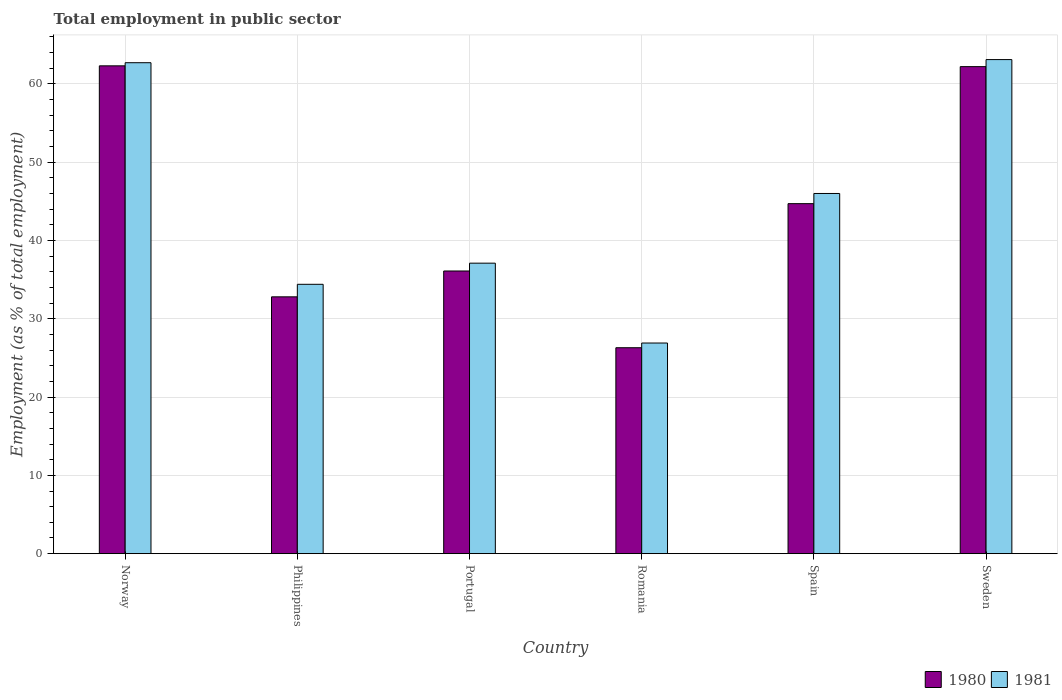How many different coloured bars are there?
Provide a short and direct response. 2. Are the number of bars per tick equal to the number of legend labels?
Keep it short and to the point. Yes. Are the number of bars on each tick of the X-axis equal?
Provide a short and direct response. Yes. In how many cases, is the number of bars for a given country not equal to the number of legend labels?
Give a very brief answer. 0. What is the employment in public sector in 1981 in Sweden?
Offer a terse response. 63.1. Across all countries, what is the maximum employment in public sector in 1980?
Provide a succinct answer. 62.3. Across all countries, what is the minimum employment in public sector in 1981?
Make the answer very short. 26.9. In which country was the employment in public sector in 1980 minimum?
Provide a short and direct response. Romania. What is the total employment in public sector in 1980 in the graph?
Your answer should be very brief. 264.4. What is the difference between the employment in public sector in 1980 in Portugal and the employment in public sector in 1981 in Romania?
Keep it short and to the point. 9.2. What is the average employment in public sector in 1980 per country?
Make the answer very short. 44.07. What is the ratio of the employment in public sector in 1980 in Norway to that in Romania?
Give a very brief answer. 2.37. What is the difference between the highest and the second highest employment in public sector in 1980?
Make the answer very short. 17.5. What is the difference between the highest and the lowest employment in public sector in 1980?
Ensure brevity in your answer.  36. Is the sum of the employment in public sector in 1980 in Philippines and Sweden greater than the maximum employment in public sector in 1981 across all countries?
Keep it short and to the point. Yes. How many bars are there?
Provide a succinct answer. 12. Are all the bars in the graph horizontal?
Your answer should be very brief. No. How many countries are there in the graph?
Offer a very short reply. 6. Are the values on the major ticks of Y-axis written in scientific E-notation?
Your response must be concise. No. Does the graph contain any zero values?
Keep it short and to the point. No. Does the graph contain grids?
Your answer should be compact. Yes. Where does the legend appear in the graph?
Offer a very short reply. Bottom right. How many legend labels are there?
Provide a succinct answer. 2. What is the title of the graph?
Your answer should be very brief. Total employment in public sector. Does "1973" appear as one of the legend labels in the graph?
Offer a terse response. No. What is the label or title of the X-axis?
Your answer should be very brief. Country. What is the label or title of the Y-axis?
Your answer should be compact. Employment (as % of total employment). What is the Employment (as % of total employment) of 1980 in Norway?
Provide a succinct answer. 62.3. What is the Employment (as % of total employment) of 1981 in Norway?
Provide a succinct answer. 62.7. What is the Employment (as % of total employment) of 1980 in Philippines?
Offer a very short reply. 32.8. What is the Employment (as % of total employment) in 1981 in Philippines?
Give a very brief answer. 34.4. What is the Employment (as % of total employment) of 1980 in Portugal?
Offer a very short reply. 36.1. What is the Employment (as % of total employment) of 1981 in Portugal?
Provide a succinct answer. 37.1. What is the Employment (as % of total employment) of 1980 in Romania?
Offer a very short reply. 26.3. What is the Employment (as % of total employment) of 1981 in Romania?
Offer a terse response. 26.9. What is the Employment (as % of total employment) of 1980 in Spain?
Offer a terse response. 44.7. What is the Employment (as % of total employment) in 1981 in Spain?
Your answer should be very brief. 46. What is the Employment (as % of total employment) of 1980 in Sweden?
Make the answer very short. 62.2. What is the Employment (as % of total employment) of 1981 in Sweden?
Offer a terse response. 63.1. Across all countries, what is the maximum Employment (as % of total employment) of 1980?
Ensure brevity in your answer.  62.3. Across all countries, what is the maximum Employment (as % of total employment) in 1981?
Offer a terse response. 63.1. Across all countries, what is the minimum Employment (as % of total employment) of 1980?
Offer a terse response. 26.3. Across all countries, what is the minimum Employment (as % of total employment) of 1981?
Your answer should be compact. 26.9. What is the total Employment (as % of total employment) of 1980 in the graph?
Your response must be concise. 264.4. What is the total Employment (as % of total employment) in 1981 in the graph?
Offer a terse response. 270.2. What is the difference between the Employment (as % of total employment) of 1980 in Norway and that in Philippines?
Your answer should be compact. 29.5. What is the difference between the Employment (as % of total employment) of 1981 in Norway and that in Philippines?
Ensure brevity in your answer.  28.3. What is the difference between the Employment (as % of total employment) in 1980 in Norway and that in Portugal?
Offer a terse response. 26.2. What is the difference between the Employment (as % of total employment) of 1981 in Norway and that in Portugal?
Your answer should be compact. 25.6. What is the difference between the Employment (as % of total employment) of 1980 in Norway and that in Romania?
Your answer should be very brief. 36. What is the difference between the Employment (as % of total employment) in 1981 in Norway and that in Romania?
Your answer should be very brief. 35.8. What is the difference between the Employment (as % of total employment) of 1981 in Norway and that in Spain?
Offer a very short reply. 16.7. What is the difference between the Employment (as % of total employment) in 1981 in Norway and that in Sweden?
Keep it short and to the point. -0.4. What is the difference between the Employment (as % of total employment) of 1981 in Philippines and that in Portugal?
Your response must be concise. -2.7. What is the difference between the Employment (as % of total employment) of 1981 in Philippines and that in Romania?
Your answer should be very brief. 7.5. What is the difference between the Employment (as % of total employment) of 1980 in Philippines and that in Spain?
Give a very brief answer. -11.9. What is the difference between the Employment (as % of total employment) in 1981 in Philippines and that in Spain?
Provide a short and direct response. -11.6. What is the difference between the Employment (as % of total employment) of 1980 in Philippines and that in Sweden?
Your answer should be compact. -29.4. What is the difference between the Employment (as % of total employment) in 1981 in Philippines and that in Sweden?
Offer a very short reply. -28.7. What is the difference between the Employment (as % of total employment) of 1980 in Portugal and that in Sweden?
Your answer should be compact. -26.1. What is the difference between the Employment (as % of total employment) of 1981 in Portugal and that in Sweden?
Make the answer very short. -26. What is the difference between the Employment (as % of total employment) in 1980 in Romania and that in Spain?
Your answer should be compact. -18.4. What is the difference between the Employment (as % of total employment) in 1981 in Romania and that in Spain?
Provide a succinct answer. -19.1. What is the difference between the Employment (as % of total employment) of 1980 in Romania and that in Sweden?
Ensure brevity in your answer.  -35.9. What is the difference between the Employment (as % of total employment) in 1981 in Romania and that in Sweden?
Provide a short and direct response. -36.2. What is the difference between the Employment (as % of total employment) in 1980 in Spain and that in Sweden?
Your answer should be compact. -17.5. What is the difference between the Employment (as % of total employment) in 1981 in Spain and that in Sweden?
Keep it short and to the point. -17.1. What is the difference between the Employment (as % of total employment) in 1980 in Norway and the Employment (as % of total employment) in 1981 in Philippines?
Provide a succinct answer. 27.9. What is the difference between the Employment (as % of total employment) of 1980 in Norway and the Employment (as % of total employment) of 1981 in Portugal?
Provide a succinct answer. 25.2. What is the difference between the Employment (as % of total employment) of 1980 in Norway and the Employment (as % of total employment) of 1981 in Romania?
Provide a short and direct response. 35.4. What is the difference between the Employment (as % of total employment) of 1980 in Norway and the Employment (as % of total employment) of 1981 in Spain?
Provide a short and direct response. 16.3. What is the difference between the Employment (as % of total employment) in 1980 in Philippines and the Employment (as % of total employment) in 1981 in Portugal?
Make the answer very short. -4.3. What is the difference between the Employment (as % of total employment) in 1980 in Philippines and the Employment (as % of total employment) in 1981 in Sweden?
Offer a terse response. -30.3. What is the difference between the Employment (as % of total employment) in 1980 in Portugal and the Employment (as % of total employment) in 1981 in Romania?
Offer a terse response. 9.2. What is the difference between the Employment (as % of total employment) in 1980 in Portugal and the Employment (as % of total employment) in 1981 in Sweden?
Provide a short and direct response. -27. What is the difference between the Employment (as % of total employment) of 1980 in Romania and the Employment (as % of total employment) of 1981 in Spain?
Provide a short and direct response. -19.7. What is the difference between the Employment (as % of total employment) of 1980 in Romania and the Employment (as % of total employment) of 1981 in Sweden?
Give a very brief answer. -36.8. What is the difference between the Employment (as % of total employment) of 1980 in Spain and the Employment (as % of total employment) of 1981 in Sweden?
Your answer should be very brief. -18.4. What is the average Employment (as % of total employment) of 1980 per country?
Provide a short and direct response. 44.07. What is the average Employment (as % of total employment) of 1981 per country?
Give a very brief answer. 45.03. What is the difference between the Employment (as % of total employment) in 1980 and Employment (as % of total employment) in 1981 in Norway?
Keep it short and to the point. -0.4. What is the difference between the Employment (as % of total employment) of 1980 and Employment (as % of total employment) of 1981 in Philippines?
Provide a short and direct response. -1.6. What is the difference between the Employment (as % of total employment) of 1980 and Employment (as % of total employment) of 1981 in Spain?
Give a very brief answer. -1.3. What is the difference between the Employment (as % of total employment) of 1980 and Employment (as % of total employment) of 1981 in Sweden?
Provide a short and direct response. -0.9. What is the ratio of the Employment (as % of total employment) of 1980 in Norway to that in Philippines?
Make the answer very short. 1.9. What is the ratio of the Employment (as % of total employment) of 1981 in Norway to that in Philippines?
Keep it short and to the point. 1.82. What is the ratio of the Employment (as % of total employment) of 1980 in Norway to that in Portugal?
Offer a terse response. 1.73. What is the ratio of the Employment (as % of total employment) of 1981 in Norway to that in Portugal?
Provide a succinct answer. 1.69. What is the ratio of the Employment (as % of total employment) in 1980 in Norway to that in Romania?
Keep it short and to the point. 2.37. What is the ratio of the Employment (as % of total employment) of 1981 in Norway to that in Romania?
Your response must be concise. 2.33. What is the ratio of the Employment (as % of total employment) of 1980 in Norway to that in Spain?
Your response must be concise. 1.39. What is the ratio of the Employment (as % of total employment) of 1981 in Norway to that in Spain?
Give a very brief answer. 1.36. What is the ratio of the Employment (as % of total employment) of 1980 in Norway to that in Sweden?
Offer a terse response. 1. What is the ratio of the Employment (as % of total employment) of 1980 in Philippines to that in Portugal?
Your answer should be very brief. 0.91. What is the ratio of the Employment (as % of total employment) of 1981 in Philippines to that in Portugal?
Keep it short and to the point. 0.93. What is the ratio of the Employment (as % of total employment) in 1980 in Philippines to that in Romania?
Provide a short and direct response. 1.25. What is the ratio of the Employment (as % of total employment) of 1981 in Philippines to that in Romania?
Offer a very short reply. 1.28. What is the ratio of the Employment (as % of total employment) of 1980 in Philippines to that in Spain?
Offer a terse response. 0.73. What is the ratio of the Employment (as % of total employment) in 1981 in Philippines to that in Spain?
Make the answer very short. 0.75. What is the ratio of the Employment (as % of total employment) in 1980 in Philippines to that in Sweden?
Make the answer very short. 0.53. What is the ratio of the Employment (as % of total employment) in 1981 in Philippines to that in Sweden?
Give a very brief answer. 0.55. What is the ratio of the Employment (as % of total employment) in 1980 in Portugal to that in Romania?
Your answer should be very brief. 1.37. What is the ratio of the Employment (as % of total employment) in 1981 in Portugal to that in Romania?
Your response must be concise. 1.38. What is the ratio of the Employment (as % of total employment) of 1980 in Portugal to that in Spain?
Provide a short and direct response. 0.81. What is the ratio of the Employment (as % of total employment) of 1981 in Portugal to that in Spain?
Ensure brevity in your answer.  0.81. What is the ratio of the Employment (as % of total employment) in 1980 in Portugal to that in Sweden?
Give a very brief answer. 0.58. What is the ratio of the Employment (as % of total employment) in 1981 in Portugal to that in Sweden?
Keep it short and to the point. 0.59. What is the ratio of the Employment (as % of total employment) of 1980 in Romania to that in Spain?
Make the answer very short. 0.59. What is the ratio of the Employment (as % of total employment) of 1981 in Romania to that in Spain?
Ensure brevity in your answer.  0.58. What is the ratio of the Employment (as % of total employment) in 1980 in Romania to that in Sweden?
Your answer should be compact. 0.42. What is the ratio of the Employment (as % of total employment) of 1981 in Romania to that in Sweden?
Your answer should be very brief. 0.43. What is the ratio of the Employment (as % of total employment) in 1980 in Spain to that in Sweden?
Your answer should be very brief. 0.72. What is the ratio of the Employment (as % of total employment) in 1981 in Spain to that in Sweden?
Keep it short and to the point. 0.73. What is the difference between the highest and the lowest Employment (as % of total employment) of 1980?
Your answer should be very brief. 36. What is the difference between the highest and the lowest Employment (as % of total employment) of 1981?
Your response must be concise. 36.2. 